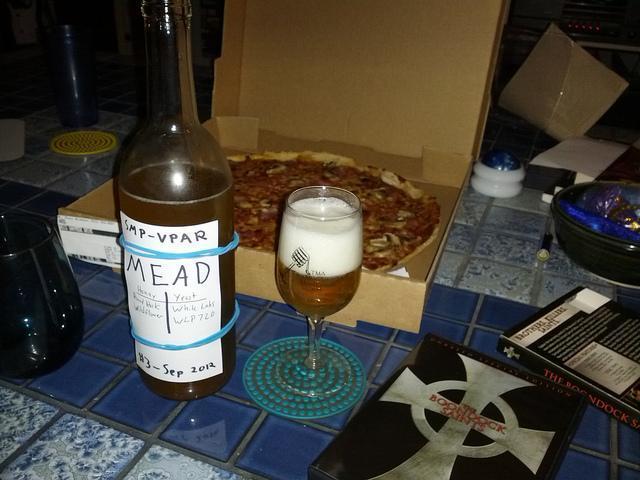How many books are in the photo?
Give a very brief answer. 2. How many donuts have blue color cream?
Give a very brief answer. 0. 